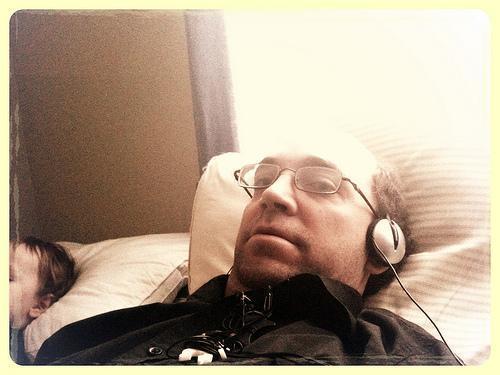How many people laying down?
Give a very brief answer. 2. 